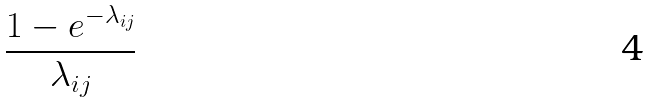<formula> <loc_0><loc_0><loc_500><loc_500>\frac { 1 - e ^ { - \lambda _ { i j } } } { \lambda _ { i j } }</formula> 